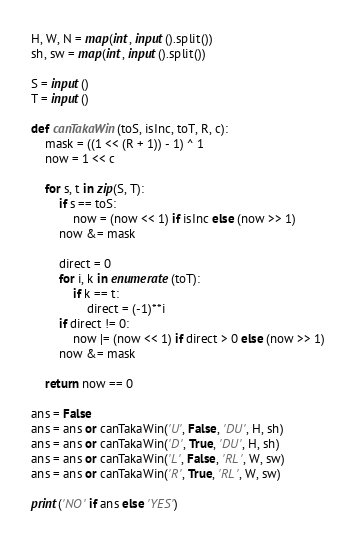<code> <loc_0><loc_0><loc_500><loc_500><_Python_>H, W, N = map(int, input().split())
sh, sw = map(int, input().split())

S = input()
T = input()

def canTakaWin(toS, isInc, toT, R, c):
    mask = ((1 << (R + 1)) - 1) ^ 1
    now = 1 << c

    for s, t in zip(S, T):
        if s == toS:
            now = (now << 1) if isInc else (now >> 1)
        now &= mask

        direct = 0
        for i, k in enumerate(toT):
            if k == t:
                direct = (-1)**i
        if direct != 0:
            now |= (now << 1) if direct > 0 else (now >> 1)
        now &= mask

    return now == 0

ans = False
ans = ans or canTakaWin('U', False, 'DU', H, sh)
ans = ans or canTakaWin('D', True, 'DU', H, sh)
ans = ans or canTakaWin('L', False, 'RL', W, sw)
ans = ans or canTakaWin('R', True, 'RL', W, sw)

print('NO' if ans else 'YES')
</code> 